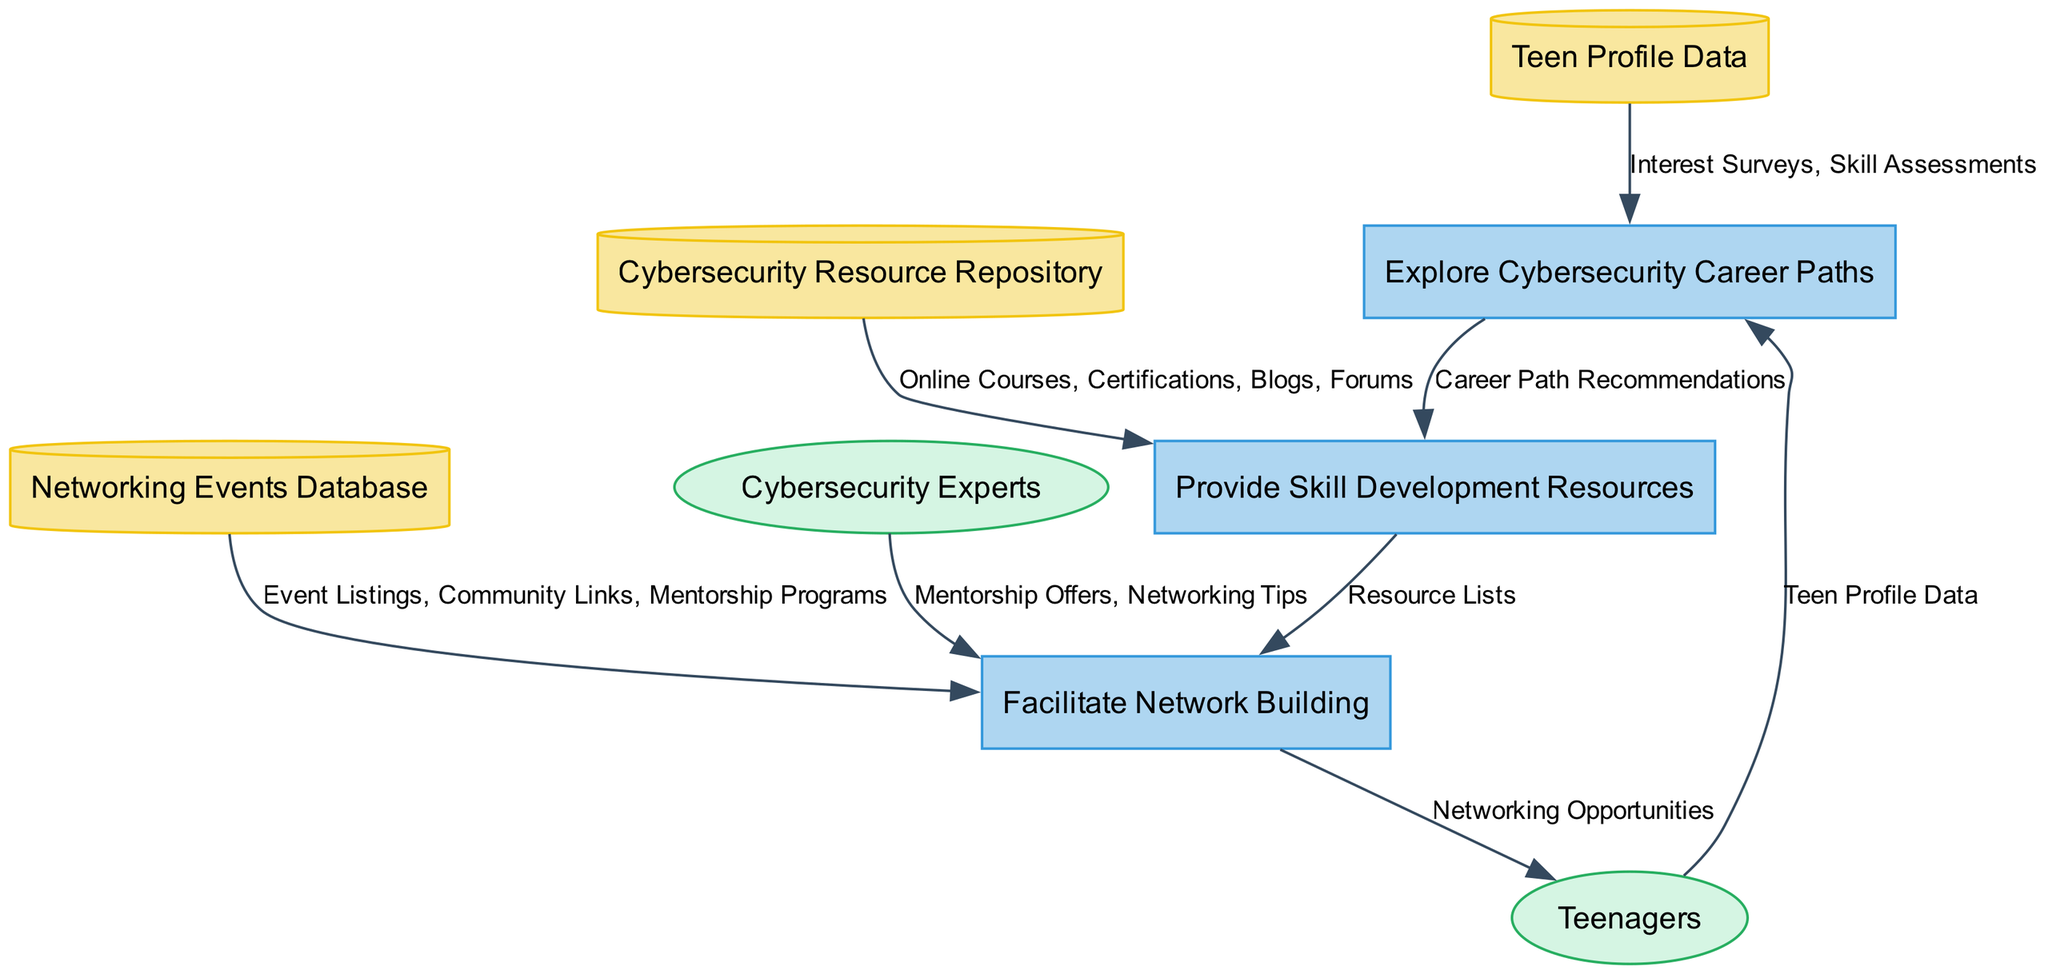What is the first process in the diagram? The first process listed in the diagram is "Explore Cybersecurity Career Paths," which is the initial action taken when teenagers seek guidance.
Answer: Explore Cybersecurity Career Paths What type of data does the "Cybersecurity Resource Repository" store? The "Cybersecurity Resource Repository" contains various skill development resources, including online courses, certifications, blogs, and forums, all tailored to enhance cybersecurity skills.
Answer: Online courses, certifications, blogs, forums How many data flows are present in the diagram? By counting the connections labeled in the data flow segment of the diagram, there are a total of eight data flows identified.
Answer: Eight What output does the "Facilitate Network Building" process generate? The process "Facilitate Network Building" generates "Networking Opportunities" as its output, which are essential for teenagers seeking connections in the field.
Answer: Networking Opportunities Which external entity provides mentorship offers? The external entity responsible for providing mentorship offers is "Cybersecurity Experts," who play a vital role in guiding teenagers.
Answer: Cybersecurity Experts What is sent from "Provide Skill Development Resources" to "Facilitate Network Building"? The output sent from "Provide Skill Development Resources" to "Facilitate Network Building" includes "Resource Lists," which contain essential resources for further network building.
Answer: Resource Lists What is the purpose of "Teen Profile Data"? "Teen Profile Data" is used to store information about teenagers' interests, skills, and career preferences, enabling tailored career path exploration.
Answer: Store information about interests, skills, career preferences What connects "Networking Events Database" to "Facilitate Network Building"? The "Networking Events Database" connects to "Facilitate Network Building" through data flows of "Event Listings," "Community Links," and "Mentorship Programs," all supporting networking.
Answer: Event Listings, Community Links, Mentorship Programs Which process uses "Teen Profile Data" as input? The process that utilizes "Teen Profile Data" as input is "Explore Cybersecurity Career Paths," which helps assess individual interests in cybersecurity roles.
Answer: Explore Cybersecurity Career Paths 